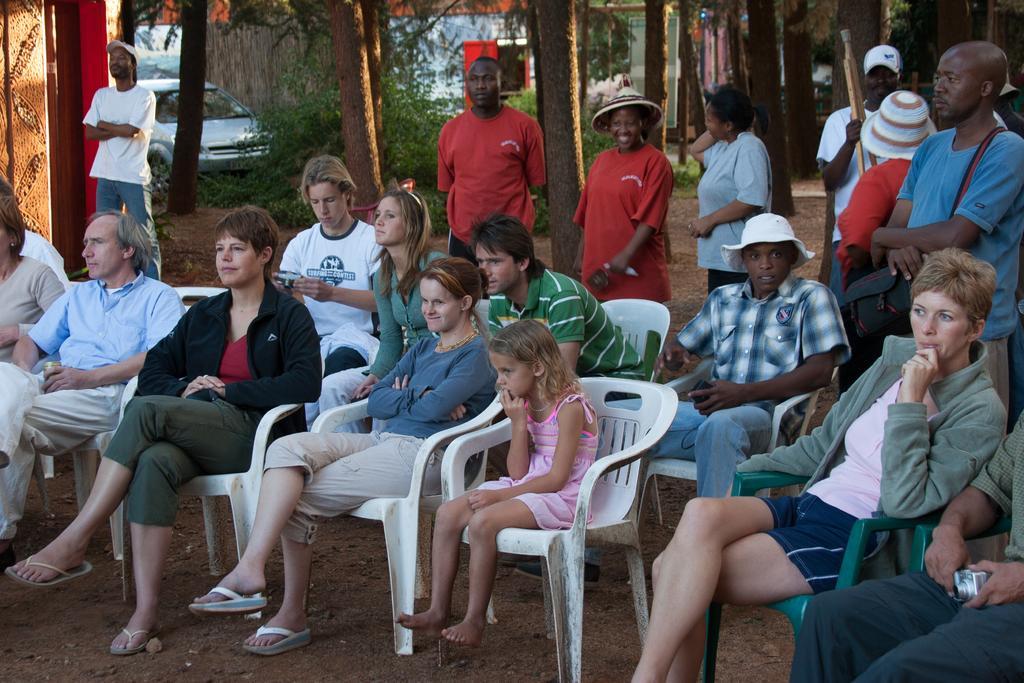Please provide a concise description of this image. In this picture there are group of people who are sitting on the chair. There are few people standing. There is a car. There are trees and a red object at the background. 